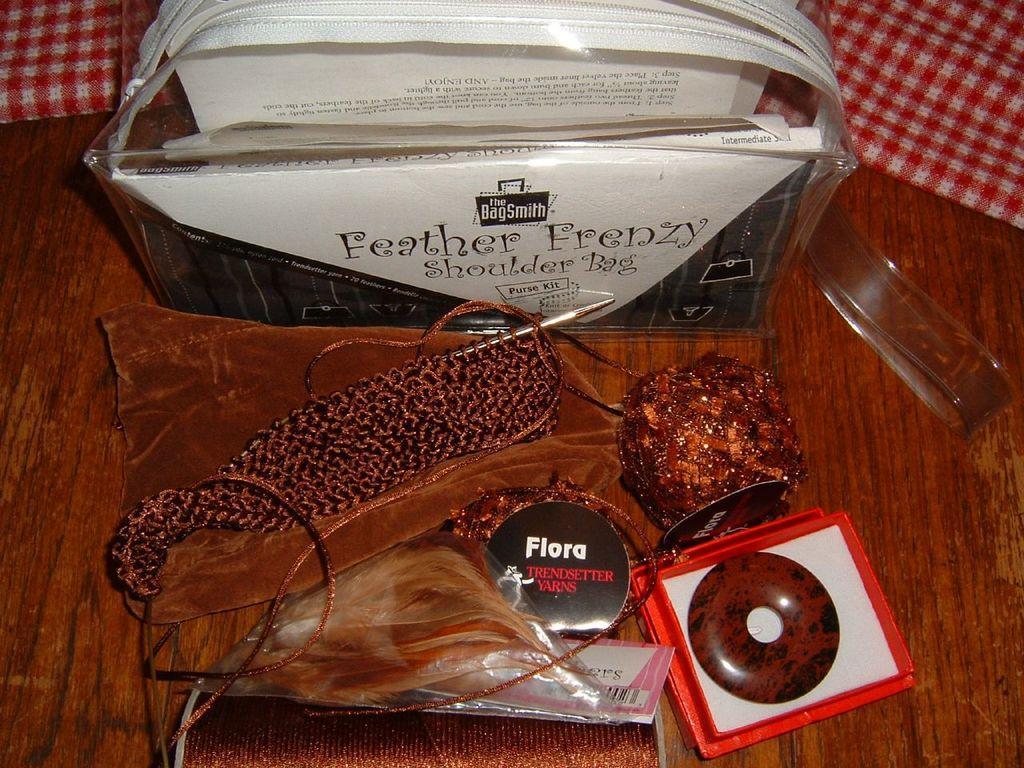Please provide a concise description of this image. At the bottom of the image we can see a table, on the table we can see some products. 